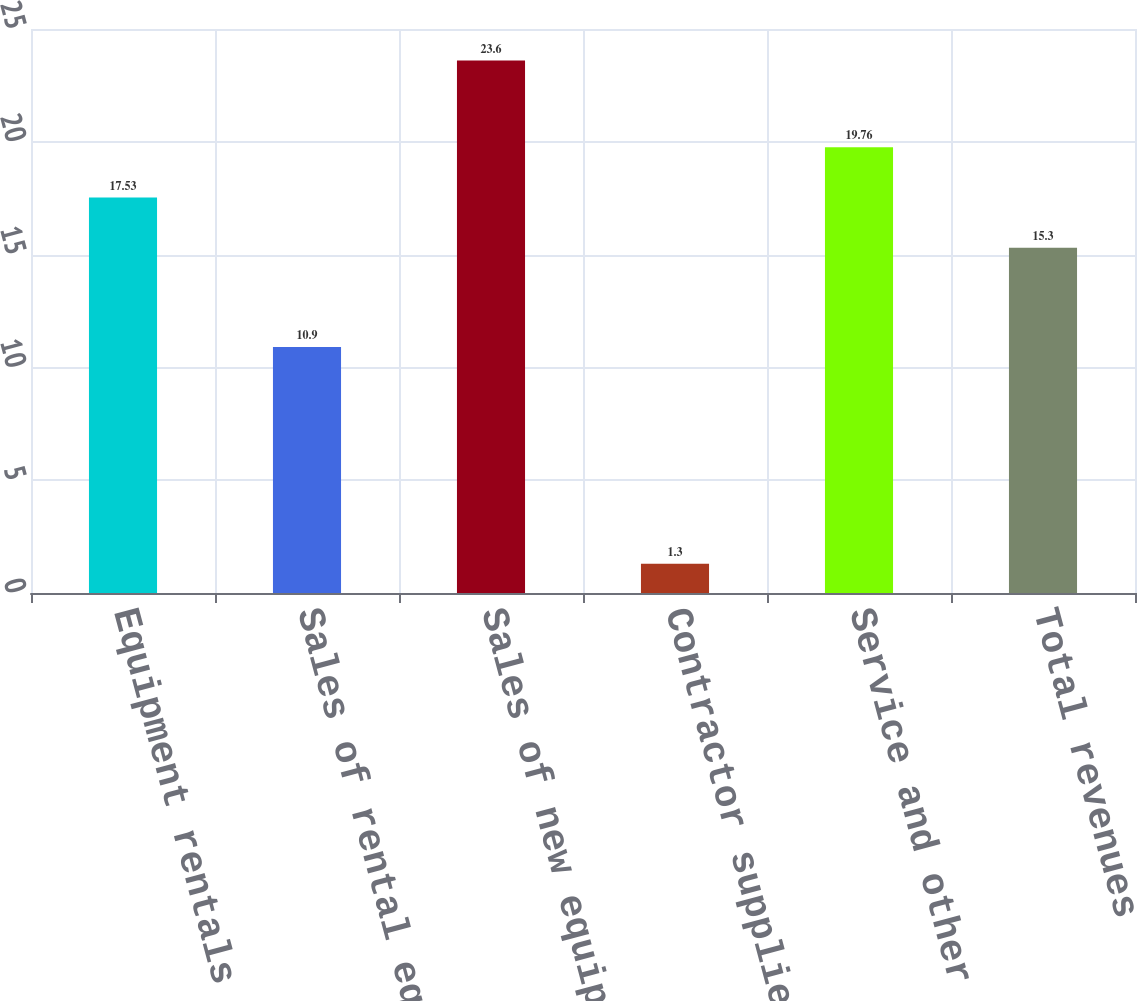Convert chart. <chart><loc_0><loc_0><loc_500><loc_500><bar_chart><fcel>Equipment rentals<fcel>Sales of rental equipment<fcel>Sales of new equipment<fcel>Contractor supplies sales<fcel>Service and other revenues<fcel>Total revenues<nl><fcel>17.53<fcel>10.9<fcel>23.6<fcel>1.3<fcel>19.76<fcel>15.3<nl></chart> 